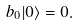Convert formula to latex. <formula><loc_0><loc_0><loc_500><loc_500>b _ { 0 } | 0 \rangle = 0 .</formula> 